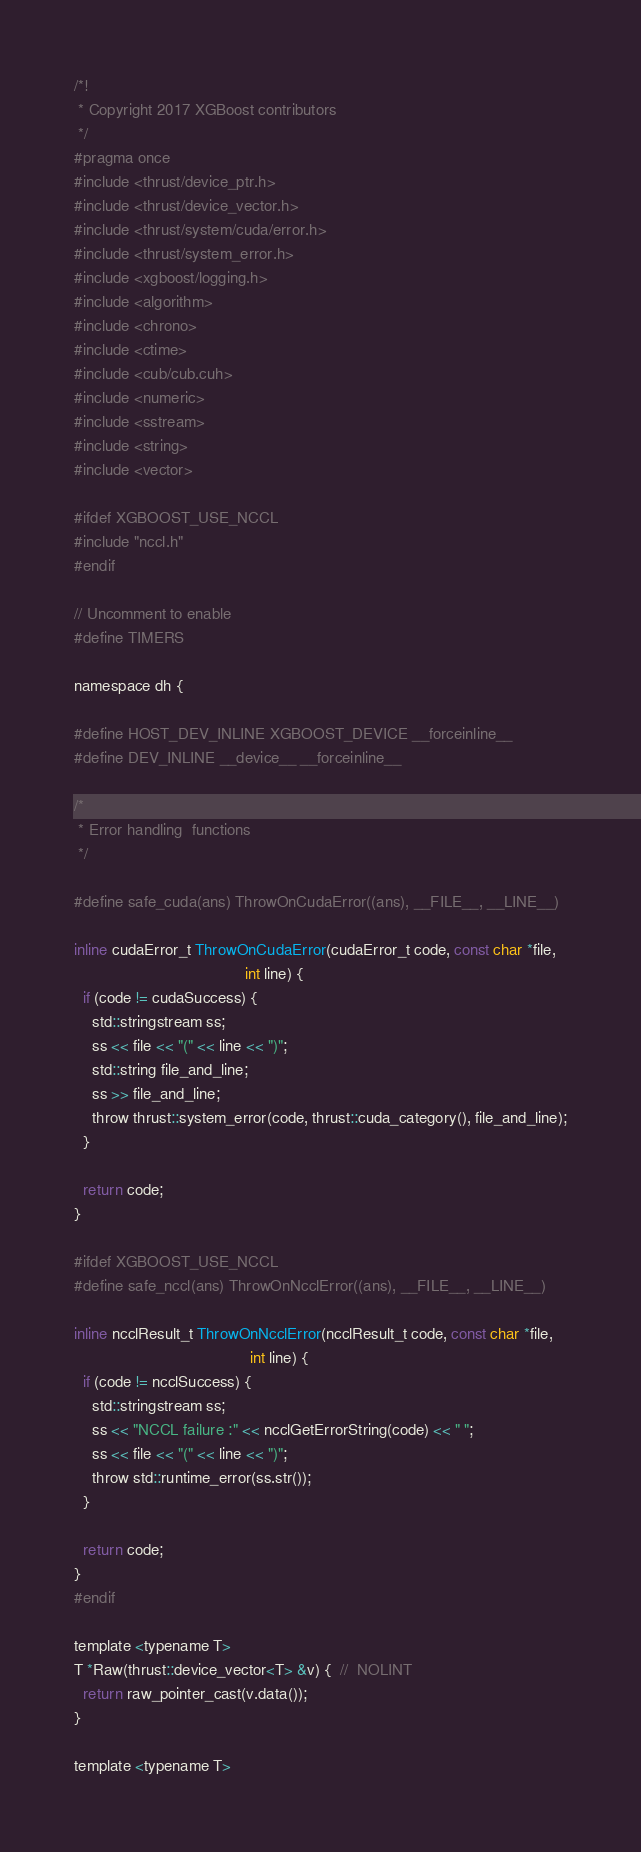Convert code to text. <code><loc_0><loc_0><loc_500><loc_500><_Cuda_>/*!
 * Copyright 2017 XGBoost contributors
 */
#pragma once
#include <thrust/device_ptr.h>
#include <thrust/device_vector.h>
#include <thrust/system/cuda/error.h>
#include <thrust/system_error.h>
#include <xgboost/logging.h>
#include <algorithm>
#include <chrono>
#include <ctime>
#include <cub/cub.cuh>
#include <numeric>
#include <sstream>
#include <string>
#include <vector>

#ifdef XGBOOST_USE_NCCL
#include "nccl.h"
#endif

// Uncomment to enable
#define TIMERS

namespace dh {

#define HOST_DEV_INLINE XGBOOST_DEVICE __forceinline__
#define DEV_INLINE __device__ __forceinline__

/*
 * Error handling  functions
 */

#define safe_cuda(ans) ThrowOnCudaError((ans), __FILE__, __LINE__)

inline cudaError_t ThrowOnCudaError(cudaError_t code, const char *file,
                                       int line) {
  if (code != cudaSuccess) {
    std::stringstream ss;
    ss << file << "(" << line << ")";
    std::string file_and_line;
    ss >> file_and_line;
    throw thrust::system_error(code, thrust::cuda_category(), file_and_line);
  }

  return code;
}

#ifdef XGBOOST_USE_NCCL
#define safe_nccl(ans) ThrowOnNcclError((ans), __FILE__, __LINE__)

inline ncclResult_t ThrowOnNcclError(ncclResult_t code, const char *file,
                                        int line) {
  if (code != ncclSuccess) {
    std::stringstream ss;
    ss << "NCCL failure :" << ncclGetErrorString(code) << " ";
    ss << file << "(" << line << ")";
    throw std::runtime_error(ss.str());
  }

  return code;
}
#endif

template <typename T>
T *Raw(thrust::device_vector<T> &v) {  //  NOLINT
  return raw_pointer_cast(v.data());
}

template <typename T></code> 